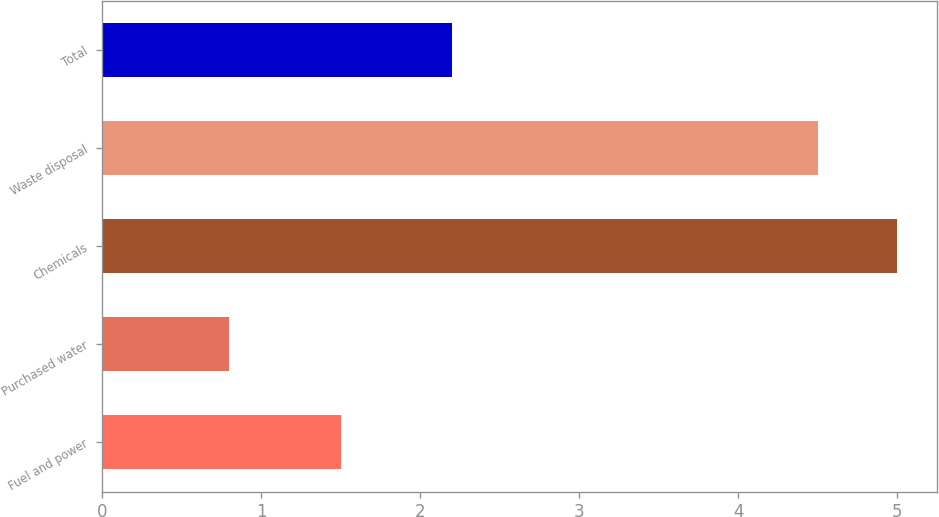Convert chart to OTSL. <chart><loc_0><loc_0><loc_500><loc_500><bar_chart><fcel>Fuel and power<fcel>Purchased water<fcel>Chemicals<fcel>Waste disposal<fcel>Total<nl><fcel>1.5<fcel>0.8<fcel>5<fcel>4.5<fcel>2.2<nl></chart> 